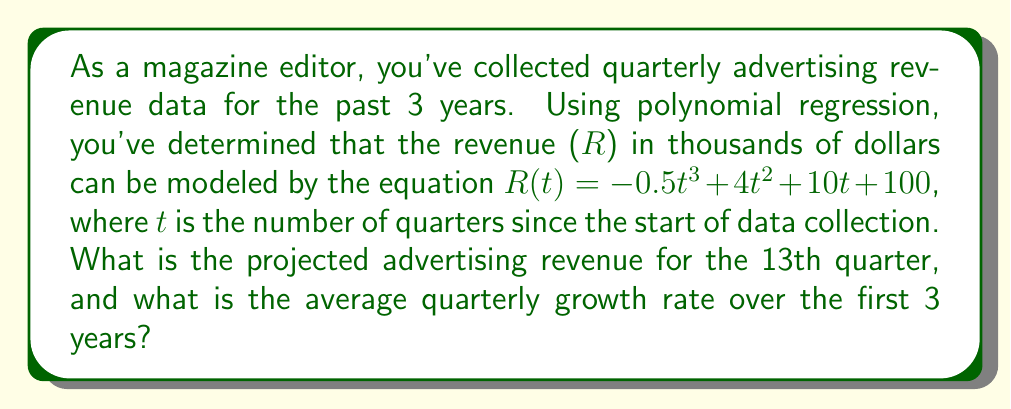Can you solve this math problem? 1. To find the projected revenue for the 13th quarter, we substitute t = 13 into the given polynomial equation:

   $R(13) = -0.5(13)^3 + 4(13)^2 + 10(13) + 100$
   $= -0.5(2197) + 4(169) + 10(13) + 100$
   $= -1098.5 + 676 + 130 + 100$
   $= -192.5$

   The revenue is in thousands of dollars, so the projected revenue is $-192,500.

2. To calculate the average quarterly growth rate, we need to:
   a) Calculate the revenue at t = 0 and t = 12 (3 years = 12 quarters)
   b) Calculate the total growth
   c) Divide the total growth by the number of quarters

   a) Revenue at t = 0:
      $R(0) = -0.5(0)^3 + 4(0)^2 + 10(0) + 100 = 100$ thousand dollars

   b) Revenue at t = 12:
      $R(12) = -0.5(12)^3 + 4(12)^2 + 10(12) + 100$
      $= -0.5(1728) + 4(144) + 120 + 100$
      $= -864 + 576 + 120 + 100$
      $= -68$ thousand dollars

   c) Total growth = $-68 - 100 = -168$ thousand dollars

   d) Average quarterly growth rate = $\frac{-168}{12} = -14$ thousand dollars per quarter
Answer: Projected revenue: $-192,500; Average quarterly growth rate: $-14,000 